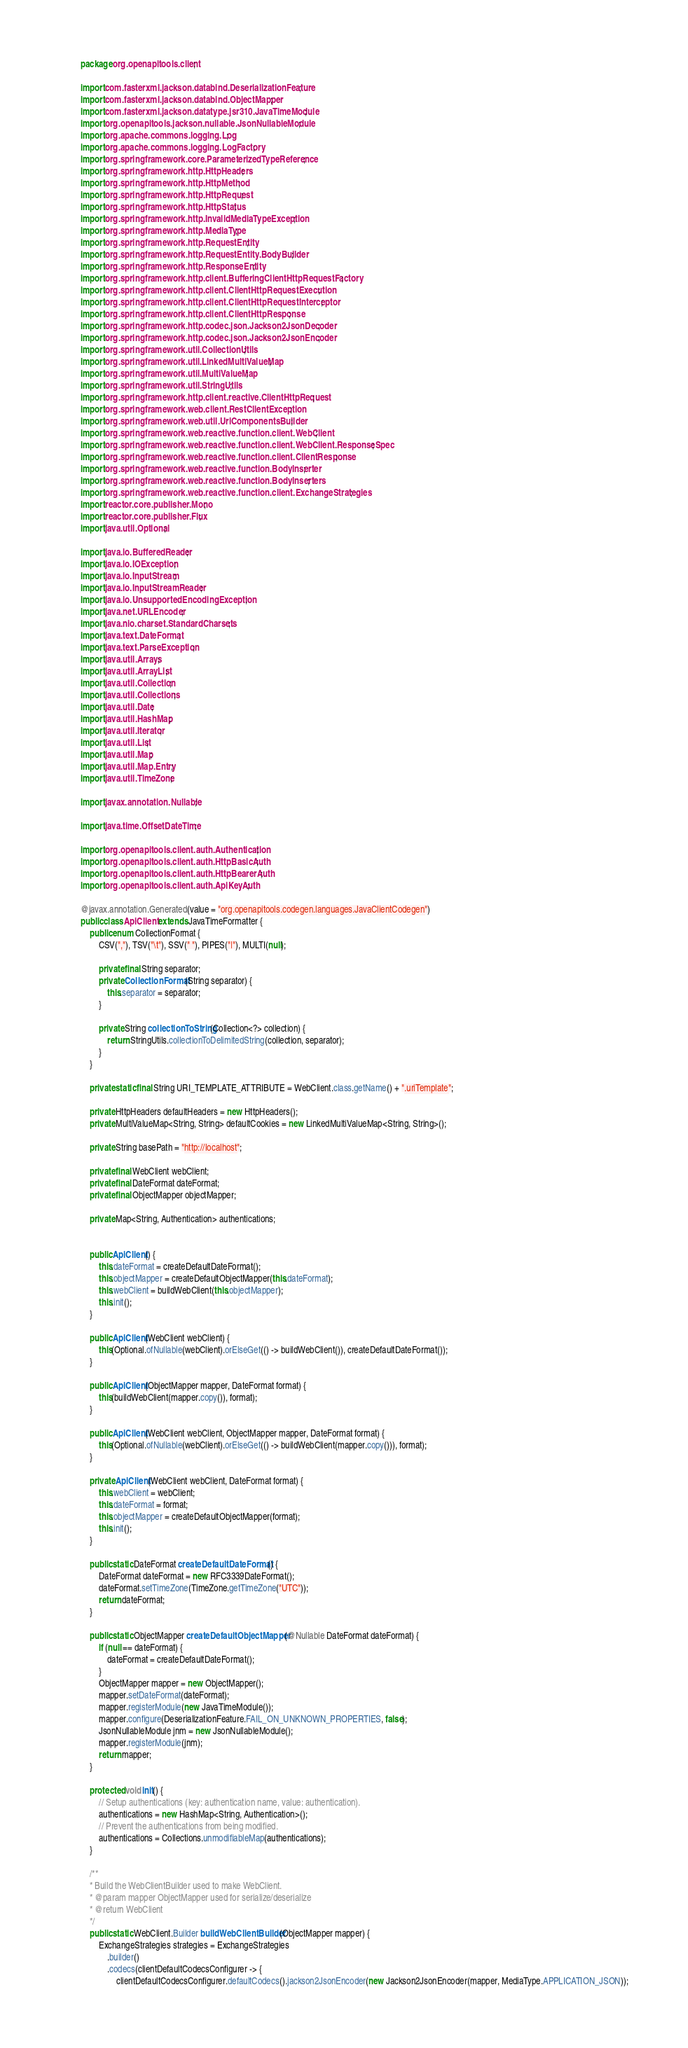Convert code to text. <code><loc_0><loc_0><loc_500><loc_500><_Java_>package org.openapitools.client;

import com.fasterxml.jackson.databind.DeserializationFeature;
import com.fasterxml.jackson.databind.ObjectMapper;
import com.fasterxml.jackson.datatype.jsr310.JavaTimeModule;
import org.openapitools.jackson.nullable.JsonNullableModule;
import org.apache.commons.logging.Log;
import org.apache.commons.logging.LogFactory;
import org.springframework.core.ParameterizedTypeReference;
import org.springframework.http.HttpHeaders;
import org.springframework.http.HttpMethod;
import org.springframework.http.HttpRequest;
import org.springframework.http.HttpStatus;
import org.springframework.http.InvalidMediaTypeException;
import org.springframework.http.MediaType;
import org.springframework.http.RequestEntity;
import org.springframework.http.RequestEntity.BodyBuilder;
import org.springframework.http.ResponseEntity;
import org.springframework.http.client.BufferingClientHttpRequestFactory;
import org.springframework.http.client.ClientHttpRequestExecution;
import org.springframework.http.client.ClientHttpRequestInterceptor;
import org.springframework.http.client.ClientHttpResponse;
import org.springframework.http.codec.json.Jackson2JsonDecoder;
import org.springframework.http.codec.json.Jackson2JsonEncoder;
import org.springframework.util.CollectionUtils;
import org.springframework.util.LinkedMultiValueMap;
import org.springframework.util.MultiValueMap;
import org.springframework.util.StringUtils;
import org.springframework.http.client.reactive.ClientHttpRequest;
import org.springframework.web.client.RestClientException;
import org.springframework.web.util.UriComponentsBuilder;
import org.springframework.web.reactive.function.client.WebClient;
import org.springframework.web.reactive.function.client.WebClient.ResponseSpec;
import org.springframework.web.reactive.function.client.ClientResponse;
import org.springframework.web.reactive.function.BodyInserter;
import org.springframework.web.reactive.function.BodyInserters;
import org.springframework.web.reactive.function.client.ExchangeStrategies;
import reactor.core.publisher.Mono;
import reactor.core.publisher.Flux;
import java.util.Optional;

import java.io.BufferedReader;
import java.io.IOException;
import java.io.InputStream;
import java.io.InputStreamReader;
import java.io.UnsupportedEncodingException;
import java.net.URLEncoder;
import java.nio.charset.StandardCharsets;
import java.text.DateFormat;
import java.text.ParseException;
import java.util.Arrays;
import java.util.ArrayList;
import java.util.Collection;
import java.util.Collections;
import java.util.Date;
import java.util.HashMap;
import java.util.Iterator;
import java.util.List;
import java.util.Map;
import java.util.Map.Entry;
import java.util.TimeZone;

import javax.annotation.Nullable;

import java.time.OffsetDateTime;

import org.openapitools.client.auth.Authentication;
import org.openapitools.client.auth.HttpBasicAuth;
import org.openapitools.client.auth.HttpBearerAuth;
import org.openapitools.client.auth.ApiKeyAuth;

@javax.annotation.Generated(value = "org.openapitools.codegen.languages.JavaClientCodegen")
public class ApiClient extends JavaTimeFormatter {
    public enum CollectionFormat {
        CSV(","), TSV("\t"), SSV(" "), PIPES("|"), MULTI(null);

        private final String separator;
        private CollectionFormat(String separator) {
            this.separator = separator;
        }

        private String collectionToString(Collection<?> collection) {
            return StringUtils.collectionToDelimitedString(collection, separator);
        }
    }

    private static final String URI_TEMPLATE_ATTRIBUTE = WebClient.class.getName() + ".uriTemplate";

    private HttpHeaders defaultHeaders = new HttpHeaders();
    private MultiValueMap<String, String> defaultCookies = new LinkedMultiValueMap<String, String>();

    private String basePath = "http://localhost";

    private final WebClient webClient;
    private final DateFormat dateFormat;
    private final ObjectMapper objectMapper;

    private Map<String, Authentication> authentications;


    public ApiClient() {
        this.dateFormat = createDefaultDateFormat();
        this.objectMapper = createDefaultObjectMapper(this.dateFormat);
        this.webClient = buildWebClient(this.objectMapper);
        this.init();
    }

    public ApiClient(WebClient webClient) {
        this(Optional.ofNullable(webClient).orElseGet(() -> buildWebClient()), createDefaultDateFormat());
    }

    public ApiClient(ObjectMapper mapper, DateFormat format) {
        this(buildWebClient(mapper.copy()), format);
    }

    public ApiClient(WebClient webClient, ObjectMapper mapper, DateFormat format) {
        this(Optional.ofNullable(webClient).orElseGet(() -> buildWebClient(mapper.copy())), format);
    }

    private ApiClient(WebClient webClient, DateFormat format) {
        this.webClient = webClient;
        this.dateFormat = format;
        this.objectMapper = createDefaultObjectMapper(format);
        this.init();
    }

    public static DateFormat createDefaultDateFormat() {
        DateFormat dateFormat = new RFC3339DateFormat();
        dateFormat.setTimeZone(TimeZone.getTimeZone("UTC"));
        return dateFormat;
    }

    public static ObjectMapper createDefaultObjectMapper(@Nullable DateFormat dateFormat) {
        if (null == dateFormat) {
            dateFormat = createDefaultDateFormat();
        }
        ObjectMapper mapper = new ObjectMapper();
        mapper.setDateFormat(dateFormat);
        mapper.registerModule(new JavaTimeModule());
        mapper.configure(DeserializationFeature.FAIL_ON_UNKNOWN_PROPERTIES, false);
        JsonNullableModule jnm = new JsonNullableModule();
        mapper.registerModule(jnm);
        return mapper;
    }

    protected void init() {
        // Setup authentications (key: authentication name, value: authentication).
        authentications = new HashMap<String, Authentication>();
        // Prevent the authentications from being modified.
        authentications = Collections.unmodifiableMap(authentications);
    }

    /**
    * Build the WebClientBuilder used to make WebClient.
    * @param mapper ObjectMapper used for serialize/deserialize
    * @return WebClient
    */
    public static WebClient.Builder buildWebClientBuilder(ObjectMapper mapper) {
        ExchangeStrategies strategies = ExchangeStrategies
            .builder()
            .codecs(clientDefaultCodecsConfigurer -> {
                clientDefaultCodecsConfigurer.defaultCodecs().jackson2JsonEncoder(new Jackson2JsonEncoder(mapper, MediaType.APPLICATION_JSON));</code> 